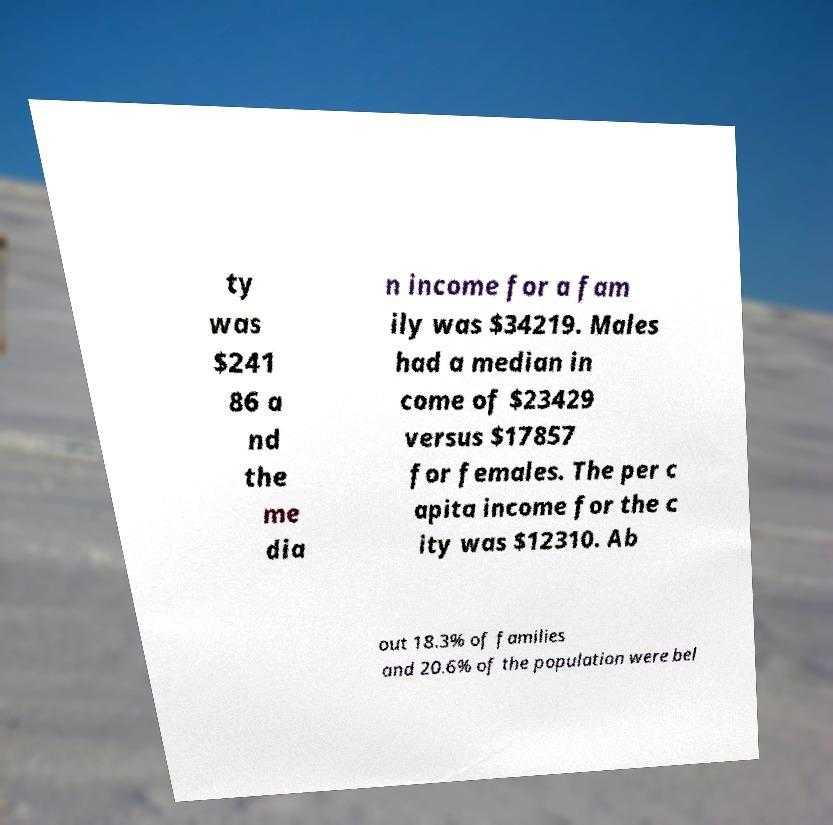There's text embedded in this image that I need extracted. Can you transcribe it verbatim? ty was $241 86 a nd the me dia n income for a fam ily was $34219. Males had a median in come of $23429 versus $17857 for females. The per c apita income for the c ity was $12310. Ab out 18.3% of families and 20.6% of the population were bel 